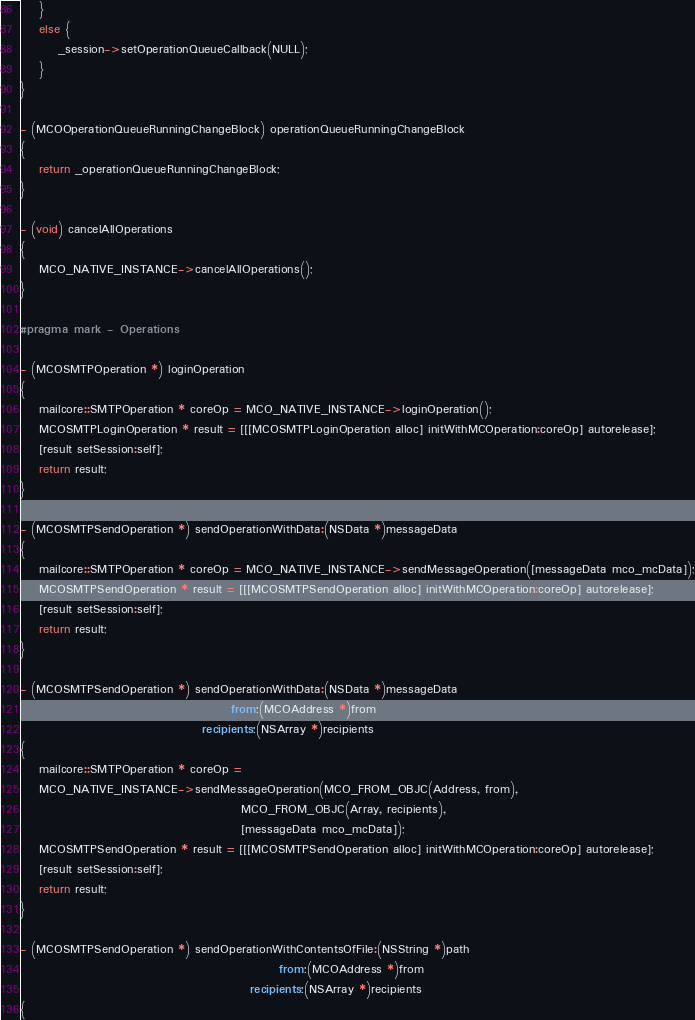Convert code to text. <code><loc_0><loc_0><loc_500><loc_500><_ObjectiveC_>    }
    else {
        _session->setOperationQueueCallback(NULL);
    }
}

- (MCOOperationQueueRunningChangeBlock) operationQueueRunningChangeBlock
{
    return _operationQueueRunningChangeBlock;
}

- (void) cancelAllOperations
{
    MCO_NATIVE_INSTANCE->cancelAllOperations();
}

#pragma mark - Operations

- (MCOSMTPOperation *) loginOperation
{
    mailcore::SMTPOperation * coreOp = MCO_NATIVE_INSTANCE->loginOperation();
    MCOSMTPLoginOperation * result = [[[MCOSMTPLoginOperation alloc] initWithMCOperation:coreOp] autorelease];
    [result setSession:self];
    return result;
}

- (MCOSMTPSendOperation *) sendOperationWithData:(NSData *)messageData
{
    mailcore::SMTPOperation * coreOp = MCO_NATIVE_INSTANCE->sendMessageOperation([messageData mco_mcData]);
    MCOSMTPSendOperation * result = [[[MCOSMTPSendOperation alloc] initWithMCOperation:coreOp] autorelease];
    [result setSession:self];
    return result;
}

- (MCOSMTPSendOperation *) sendOperationWithData:(NSData *)messageData
                                            from:(MCOAddress *)from
                                      recipients:(NSArray *)recipients
{
    mailcore::SMTPOperation * coreOp =
    MCO_NATIVE_INSTANCE->sendMessageOperation(MCO_FROM_OBJC(Address, from),
                                              MCO_FROM_OBJC(Array, recipients),
                                              [messageData mco_mcData]);
    MCOSMTPSendOperation * result = [[[MCOSMTPSendOperation alloc] initWithMCOperation:coreOp] autorelease];
    [result setSession:self];
    return result;
}

- (MCOSMTPSendOperation *) sendOperationWithContentsOfFile:(NSString *)path
                                                      from:(MCOAddress *)from
                                                recipients:(NSArray *)recipients
{</code> 